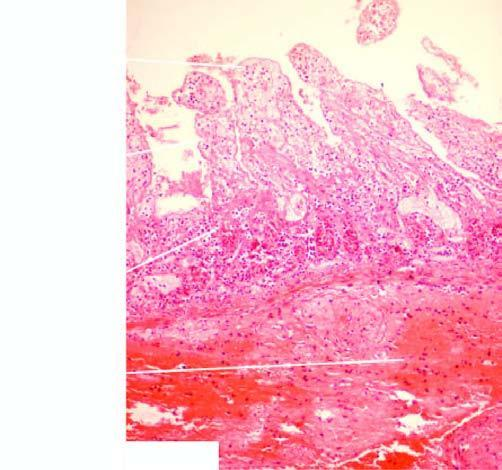what is marked at the line of demarcation between the infarcted and normal bowel?
Answer the question using a single word or phrase. Inflammatory cell infiltration 